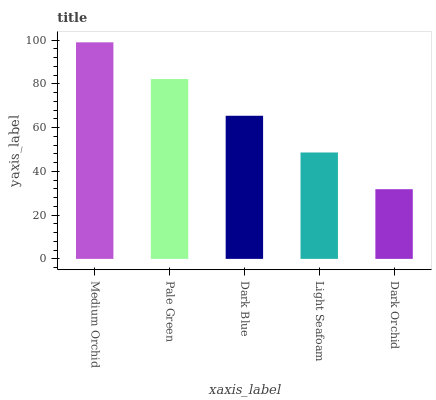Is Dark Orchid the minimum?
Answer yes or no. Yes. Is Medium Orchid the maximum?
Answer yes or no. Yes. Is Pale Green the minimum?
Answer yes or no. No. Is Pale Green the maximum?
Answer yes or no. No. Is Medium Orchid greater than Pale Green?
Answer yes or no. Yes. Is Pale Green less than Medium Orchid?
Answer yes or no. Yes. Is Pale Green greater than Medium Orchid?
Answer yes or no. No. Is Medium Orchid less than Pale Green?
Answer yes or no. No. Is Dark Blue the high median?
Answer yes or no. Yes. Is Dark Blue the low median?
Answer yes or no. Yes. Is Light Seafoam the high median?
Answer yes or no. No. Is Light Seafoam the low median?
Answer yes or no. No. 